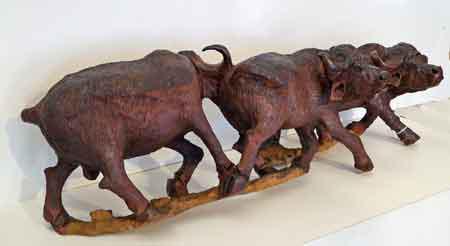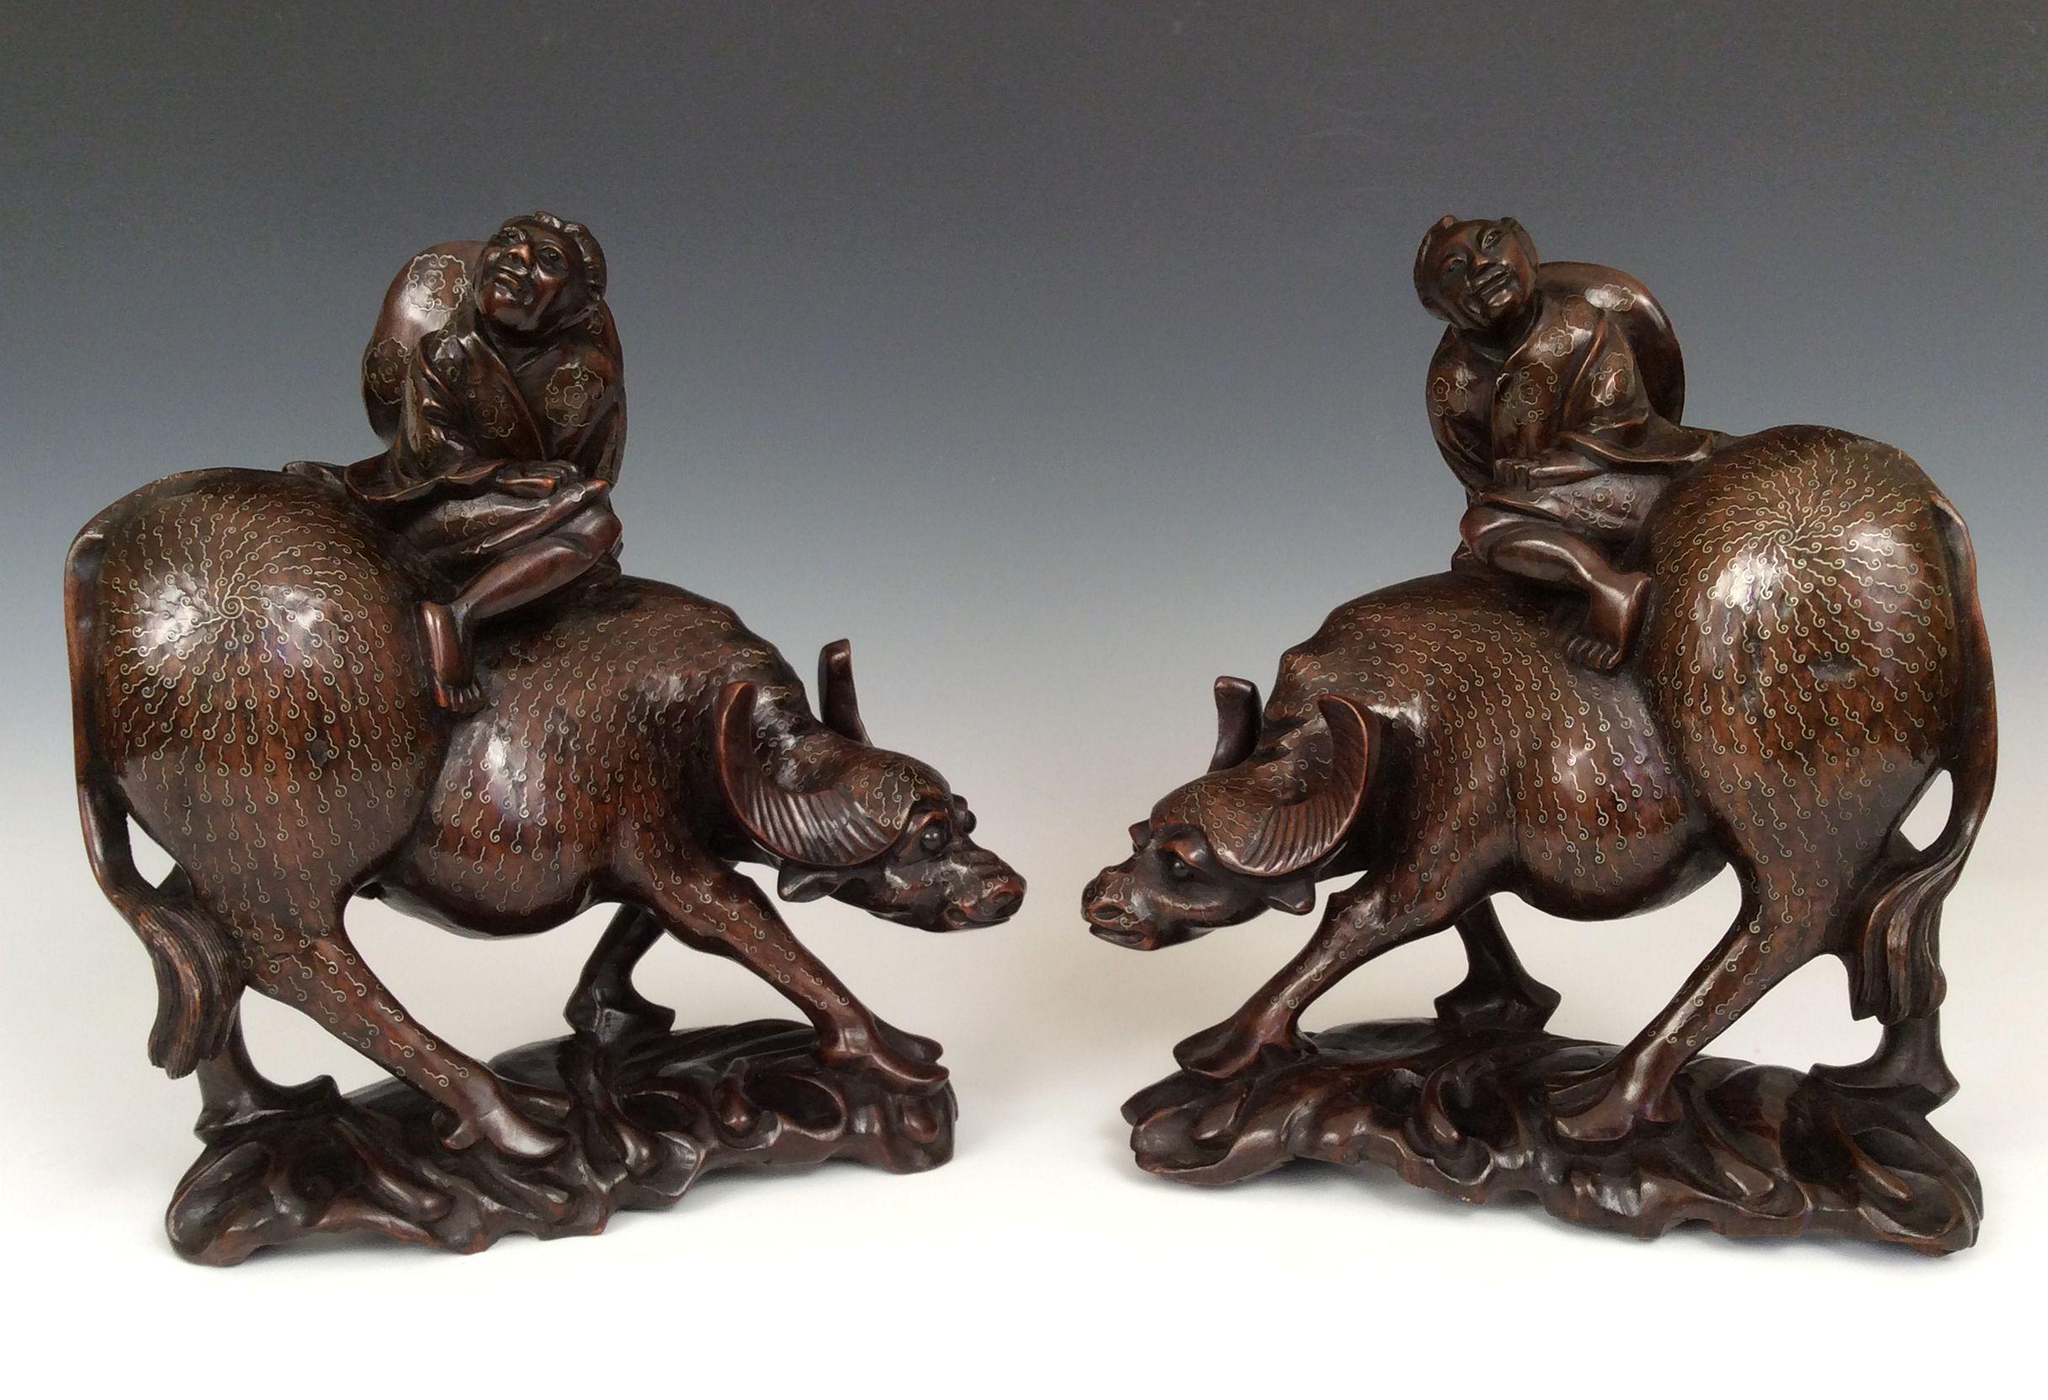The first image is the image on the left, the second image is the image on the right. Evaluate the accuracy of this statement regarding the images: "There are exactly two animals.". Is it true? Answer yes or no. No. 